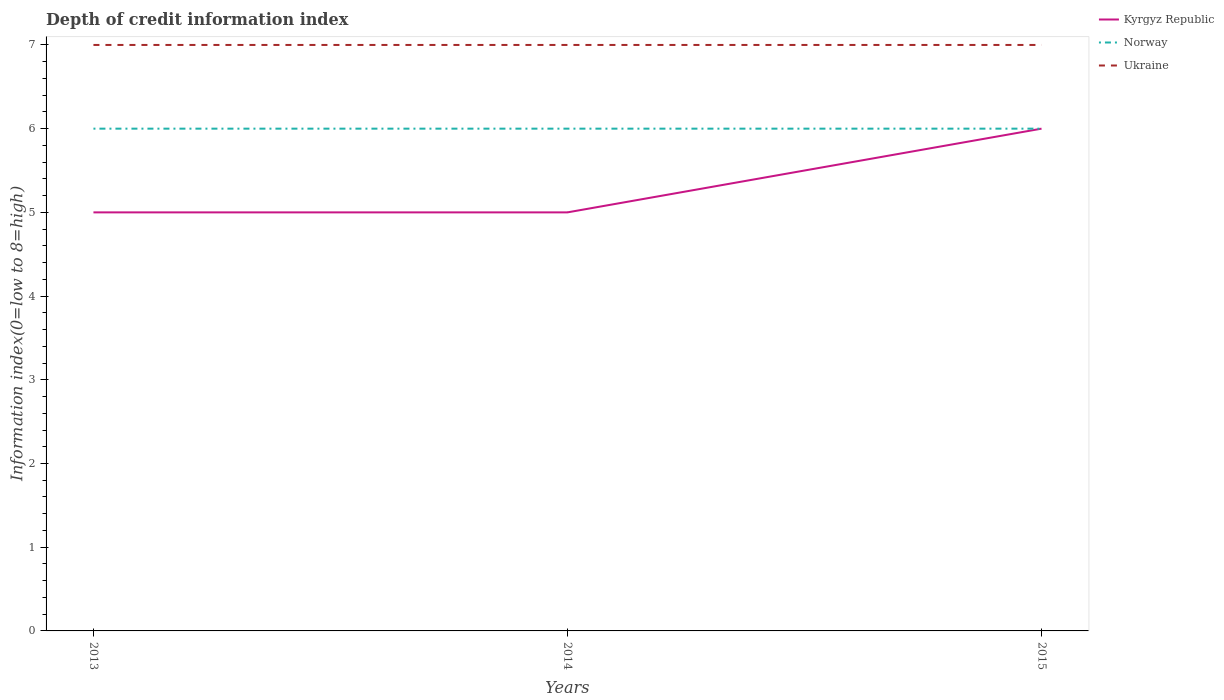How many different coloured lines are there?
Provide a short and direct response. 3. Across all years, what is the maximum information index in Ukraine?
Provide a succinct answer. 7. What is the difference between the highest and the lowest information index in Kyrgyz Republic?
Give a very brief answer. 1. Is the information index in Ukraine strictly greater than the information index in Kyrgyz Republic over the years?
Offer a very short reply. No. How many years are there in the graph?
Offer a very short reply. 3. What is the difference between two consecutive major ticks on the Y-axis?
Your answer should be very brief. 1. Are the values on the major ticks of Y-axis written in scientific E-notation?
Your answer should be very brief. No. What is the title of the graph?
Provide a short and direct response. Depth of credit information index. What is the label or title of the X-axis?
Provide a short and direct response. Years. What is the label or title of the Y-axis?
Ensure brevity in your answer.  Information index(0=low to 8=high). What is the Information index(0=low to 8=high) in Kyrgyz Republic in 2013?
Provide a succinct answer. 5. What is the Information index(0=low to 8=high) in Norway in 2013?
Your answer should be very brief. 6. What is the Information index(0=low to 8=high) of Ukraine in 2013?
Give a very brief answer. 7. What is the Information index(0=low to 8=high) in Ukraine in 2015?
Your answer should be compact. 7. Across all years, what is the maximum Information index(0=low to 8=high) in Kyrgyz Republic?
Make the answer very short. 6. Across all years, what is the minimum Information index(0=low to 8=high) of Kyrgyz Republic?
Ensure brevity in your answer.  5. Across all years, what is the minimum Information index(0=low to 8=high) in Norway?
Offer a terse response. 6. What is the difference between the Information index(0=low to 8=high) in Kyrgyz Republic in 2013 and that in 2014?
Provide a short and direct response. 0. What is the difference between the Information index(0=low to 8=high) in Norway in 2013 and that in 2015?
Provide a short and direct response. 0. What is the difference between the Information index(0=low to 8=high) in Ukraine in 2013 and that in 2015?
Give a very brief answer. 0. What is the difference between the Information index(0=low to 8=high) of Kyrgyz Republic in 2014 and that in 2015?
Your response must be concise. -1. What is the difference between the Information index(0=low to 8=high) of Kyrgyz Republic in 2013 and the Information index(0=low to 8=high) of Norway in 2014?
Your response must be concise. -1. What is the difference between the Information index(0=low to 8=high) in Norway in 2013 and the Information index(0=low to 8=high) in Ukraine in 2014?
Your answer should be compact. -1. What is the difference between the Information index(0=low to 8=high) in Kyrgyz Republic in 2013 and the Information index(0=low to 8=high) in Norway in 2015?
Offer a very short reply. -1. What is the difference between the Information index(0=low to 8=high) of Kyrgyz Republic in 2013 and the Information index(0=low to 8=high) of Ukraine in 2015?
Offer a terse response. -2. What is the difference between the Information index(0=low to 8=high) of Norway in 2013 and the Information index(0=low to 8=high) of Ukraine in 2015?
Your answer should be very brief. -1. What is the difference between the Information index(0=low to 8=high) in Kyrgyz Republic in 2014 and the Information index(0=low to 8=high) in Ukraine in 2015?
Provide a short and direct response. -2. What is the average Information index(0=low to 8=high) of Kyrgyz Republic per year?
Offer a very short reply. 5.33. In the year 2013, what is the difference between the Information index(0=low to 8=high) of Kyrgyz Republic and Information index(0=low to 8=high) of Norway?
Your answer should be very brief. -1. In the year 2013, what is the difference between the Information index(0=low to 8=high) of Norway and Information index(0=low to 8=high) of Ukraine?
Offer a very short reply. -1. In the year 2014, what is the difference between the Information index(0=low to 8=high) of Kyrgyz Republic and Information index(0=low to 8=high) of Norway?
Give a very brief answer. -1. In the year 2015, what is the difference between the Information index(0=low to 8=high) in Kyrgyz Republic and Information index(0=low to 8=high) in Norway?
Offer a very short reply. 0. In the year 2015, what is the difference between the Information index(0=low to 8=high) of Kyrgyz Republic and Information index(0=low to 8=high) of Ukraine?
Give a very brief answer. -1. In the year 2015, what is the difference between the Information index(0=low to 8=high) of Norway and Information index(0=low to 8=high) of Ukraine?
Offer a terse response. -1. What is the ratio of the Information index(0=low to 8=high) of Norway in 2013 to that in 2014?
Offer a very short reply. 1. What is the ratio of the Information index(0=low to 8=high) in Kyrgyz Republic in 2013 to that in 2015?
Ensure brevity in your answer.  0.83. What is the ratio of the Information index(0=low to 8=high) in Norway in 2014 to that in 2015?
Your answer should be very brief. 1. What is the difference between the highest and the second highest Information index(0=low to 8=high) in Kyrgyz Republic?
Offer a terse response. 1. What is the difference between the highest and the second highest Information index(0=low to 8=high) of Norway?
Provide a succinct answer. 0. What is the difference between the highest and the second highest Information index(0=low to 8=high) in Ukraine?
Make the answer very short. 0. 